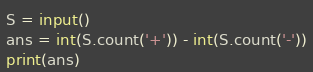Convert code to text. <code><loc_0><loc_0><loc_500><loc_500><_Python_>S = input()
ans = int(S.count('+')) - int(S.count('-'))
print(ans)</code> 